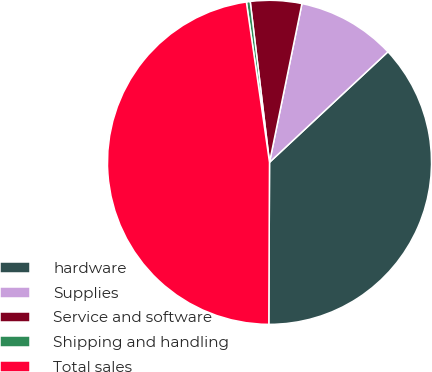<chart> <loc_0><loc_0><loc_500><loc_500><pie_chart><fcel>hardware<fcel>Supplies<fcel>Service and software<fcel>Shipping and handling<fcel>Total sales<nl><fcel>37.02%<fcel>9.84%<fcel>5.11%<fcel>0.38%<fcel>47.65%<nl></chart> 